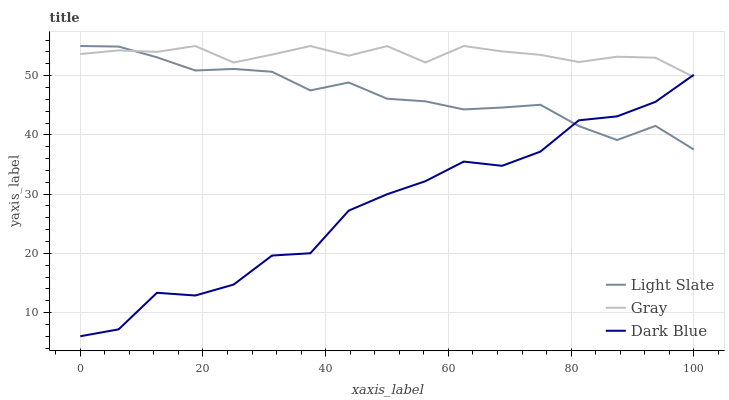Does Dark Blue have the minimum area under the curve?
Answer yes or no. Yes. Does Gray have the maximum area under the curve?
Answer yes or no. Yes. Does Gray have the minimum area under the curve?
Answer yes or no. No. Does Dark Blue have the maximum area under the curve?
Answer yes or no. No. Is Gray the smoothest?
Answer yes or no. Yes. Is Dark Blue the roughest?
Answer yes or no. Yes. Is Dark Blue the smoothest?
Answer yes or no. No. Is Gray the roughest?
Answer yes or no. No. Does Dark Blue have the lowest value?
Answer yes or no. Yes. Does Gray have the lowest value?
Answer yes or no. No. Does Gray have the highest value?
Answer yes or no. Yes. Does Dark Blue have the highest value?
Answer yes or no. No. Does Dark Blue intersect Light Slate?
Answer yes or no. Yes. Is Dark Blue less than Light Slate?
Answer yes or no. No. Is Dark Blue greater than Light Slate?
Answer yes or no. No. 